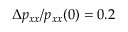<formula> <loc_0><loc_0><loc_500><loc_500>\Delta p _ { x x } / p _ { x x } ( 0 ) = 0 . 2 \</formula> 